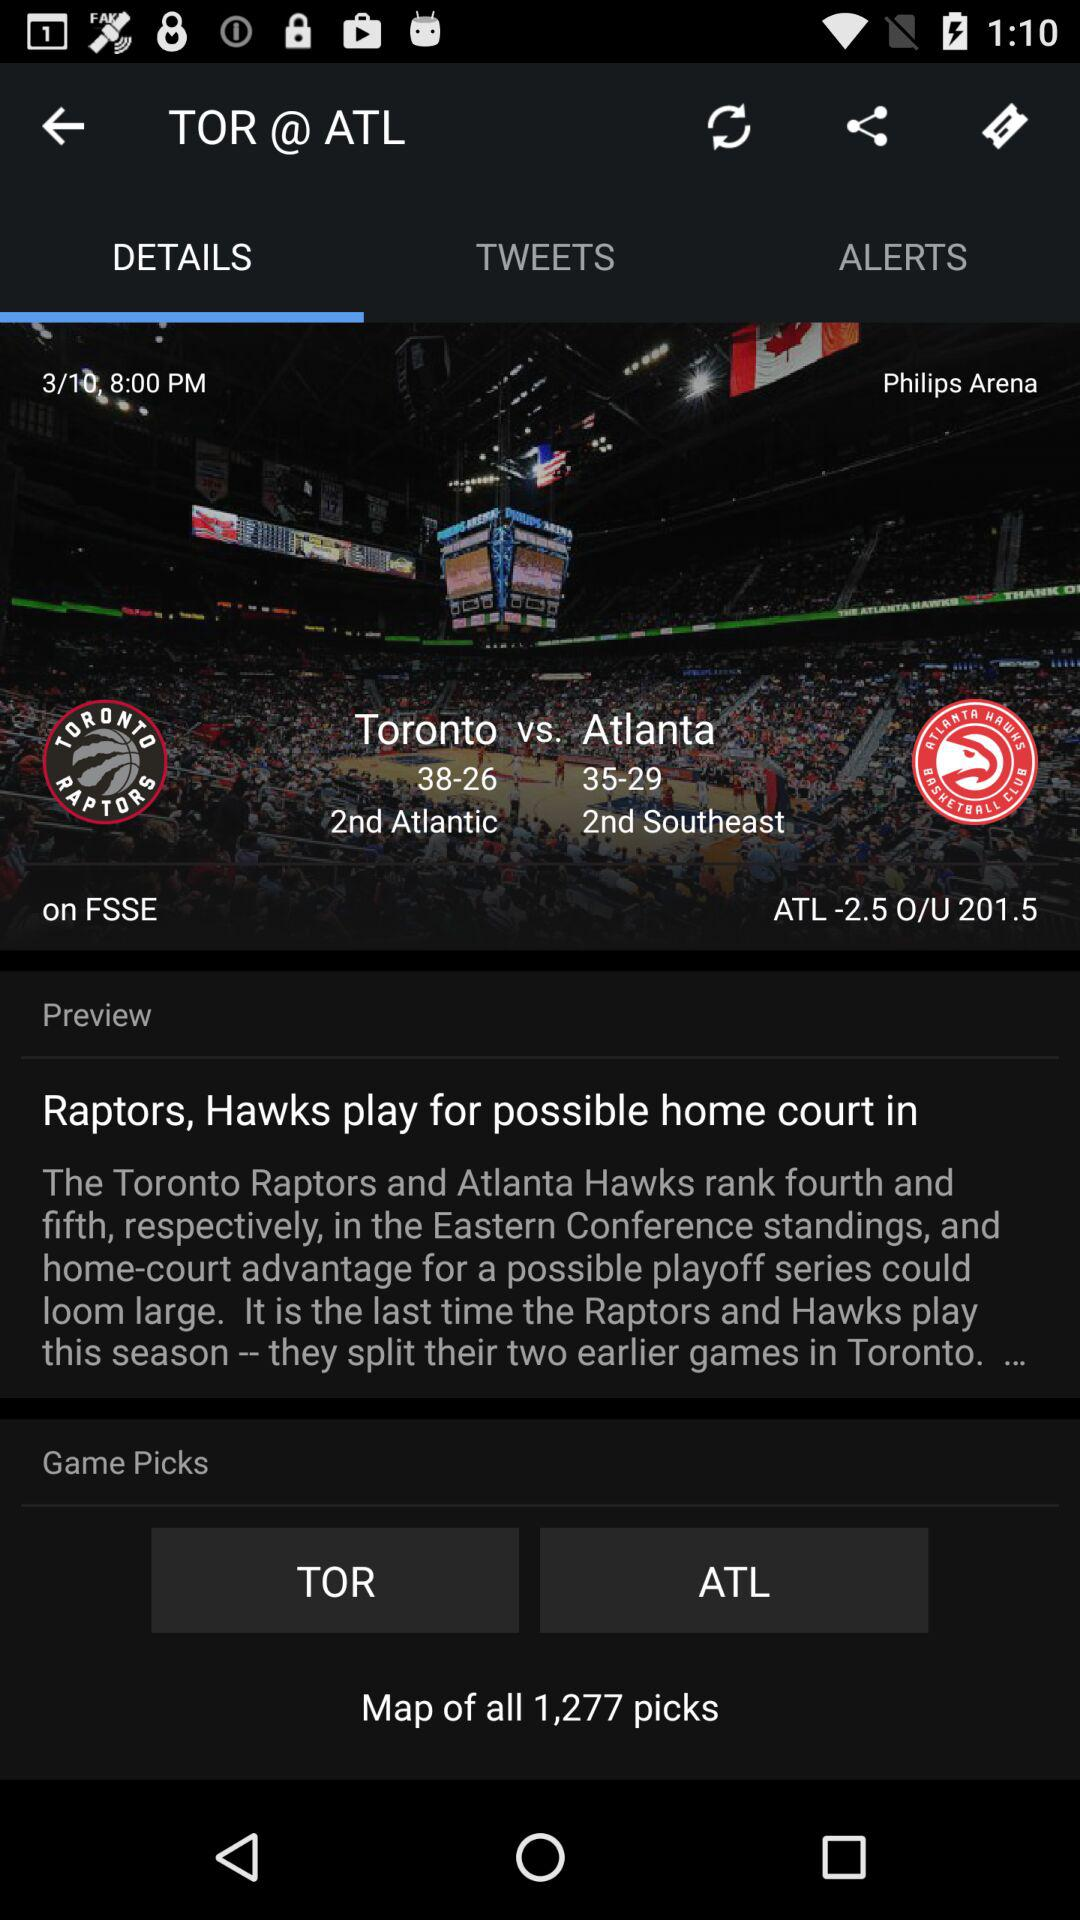How many more points does Atlanta have than Toronto?
Answer the question using a single word or phrase. 3 